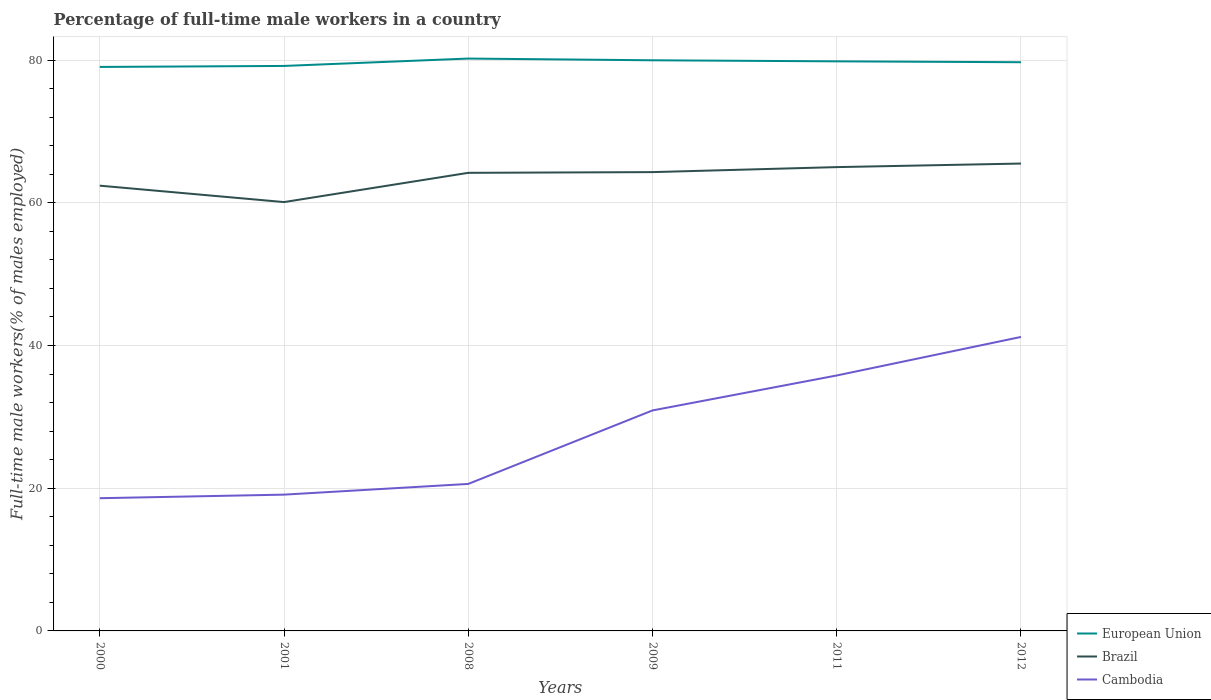How many different coloured lines are there?
Ensure brevity in your answer.  3. Is the number of lines equal to the number of legend labels?
Provide a short and direct response. Yes. Across all years, what is the maximum percentage of full-time male workers in European Union?
Keep it short and to the point. 79.04. In which year was the percentage of full-time male workers in European Union maximum?
Ensure brevity in your answer.  2000. What is the total percentage of full-time male workers in Brazil in the graph?
Give a very brief answer. -4.2. What is the difference between the highest and the second highest percentage of full-time male workers in Cambodia?
Your response must be concise. 22.6. Is the percentage of full-time male workers in Cambodia strictly greater than the percentage of full-time male workers in Brazil over the years?
Give a very brief answer. Yes. How many lines are there?
Your response must be concise. 3. What is the difference between two consecutive major ticks on the Y-axis?
Keep it short and to the point. 20. Does the graph contain any zero values?
Keep it short and to the point. No. Does the graph contain grids?
Provide a short and direct response. Yes. How many legend labels are there?
Provide a short and direct response. 3. What is the title of the graph?
Ensure brevity in your answer.  Percentage of full-time male workers in a country. What is the label or title of the Y-axis?
Provide a short and direct response. Full-time male workers(% of males employed). What is the Full-time male workers(% of males employed) of European Union in 2000?
Provide a short and direct response. 79.04. What is the Full-time male workers(% of males employed) in Brazil in 2000?
Offer a terse response. 62.4. What is the Full-time male workers(% of males employed) in Cambodia in 2000?
Keep it short and to the point. 18.6. What is the Full-time male workers(% of males employed) in European Union in 2001?
Your answer should be compact. 79.18. What is the Full-time male workers(% of males employed) of Brazil in 2001?
Provide a short and direct response. 60.1. What is the Full-time male workers(% of males employed) in Cambodia in 2001?
Offer a terse response. 19.1. What is the Full-time male workers(% of males employed) of European Union in 2008?
Keep it short and to the point. 80.21. What is the Full-time male workers(% of males employed) of Brazil in 2008?
Offer a very short reply. 64.2. What is the Full-time male workers(% of males employed) of Cambodia in 2008?
Offer a terse response. 20.6. What is the Full-time male workers(% of males employed) of European Union in 2009?
Your answer should be very brief. 79.97. What is the Full-time male workers(% of males employed) of Brazil in 2009?
Offer a terse response. 64.3. What is the Full-time male workers(% of males employed) in Cambodia in 2009?
Provide a succinct answer. 30.9. What is the Full-time male workers(% of males employed) in European Union in 2011?
Your answer should be very brief. 79.82. What is the Full-time male workers(% of males employed) in Cambodia in 2011?
Offer a very short reply. 35.8. What is the Full-time male workers(% of males employed) of European Union in 2012?
Provide a short and direct response. 79.7. What is the Full-time male workers(% of males employed) in Brazil in 2012?
Your answer should be compact. 65.5. What is the Full-time male workers(% of males employed) in Cambodia in 2012?
Provide a short and direct response. 41.2. Across all years, what is the maximum Full-time male workers(% of males employed) of European Union?
Your answer should be compact. 80.21. Across all years, what is the maximum Full-time male workers(% of males employed) of Brazil?
Offer a terse response. 65.5. Across all years, what is the maximum Full-time male workers(% of males employed) of Cambodia?
Your answer should be very brief. 41.2. Across all years, what is the minimum Full-time male workers(% of males employed) in European Union?
Offer a very short reply. 79.04. Across all years, what is the minimum Full-time male workers(% of males employed) of Brazil?
Provide a succinct answer. 60.1. Across all years, what is the minimum Full-time male workers(% of males employed) in Cambodia?
Your answer should be very brief. 18.6. What is the total Full-time male workers(% of males employed) of European Union in the graph?
Make the answer very short. 477.93. What is the total Full-time male workers(% of males employed) of Brazil in the graph?
Your response must be concise. 381.5. What is the total Full-time male workers(% of males employed) of Cambodia in the graph?
Offer a very short reply. 166.2. What is the difference between the Full-time male workers(% of males employed) in European Union in 2000 and that in 2001?
Offer a terse response. -0.14. What is the difference between the Full-time male workers(% of males employed) in European Union in 2000 and that in 2008?
Your answer should be very brief. -1.18. What is the difference between the Full-time male workers(% of males employed) of European Union in 2000 and that in 2009?
Provide a short and direct response. -0.93. What is the difference between the Full-time male workers(% of males employed) in European Union in 2000 and that in 2011?
Offer a terse response. -0.78. What is the difference between the Full-time male workers(% of males employed) in Cambodia in 2000 and that in 2011?
Your response must be concise. -17.2. What is the difference between the Full-time male workers(% of males employed) in European Union in 2000 and that in 2012?
Provide a succinct answer. -0.66. What is the difference between the Full-time male workers(% of males employed) of Brazil in 2000 and that in 2012?
Offer a very short reply. -3.1. What is the difference between the Full-time male workers(% of males employed) of Cambodia in 2000 and that in 2012?
Your response must be concise. -22.6. What is the difference between the Full-time male workers(% of males employed) of European Union in 2001 and that in 2008?
Offer a very short reply. -1.03. What is the difference between the Full-time male workers(% of males employed) in European Union in 2001 and that in 2009?
Offer a terse response. -0.79. What is the difference between the Full-time male workers(% of males employed) of Brazil in 2001 and that in 2009?
Provide a succinct answer. -4.2. What is the difference between the Full-time male workers(% of males employed) of Cambodia in 2001 and that in 2009?
Provide a succinct answer. -11.8. What is the difference between the Full-time male workers(% of males employed) of European Union in 2001 and that in 2011?
Your response must be concise. -0.64. What is the difference between the Full-time male workers(% of males employed) in Brazil in 2001 and that in 2011?
Your answer should be very brief. -4.9. What is the difference between the Full-time male workers(% of males employed) of Cambodia in 2001 and that in 2011?
Your answer should be very brief. -16.7. What is the difference between the Full-time male workers(% of males employed) in European Union in 2001 and that in 2012?
Offer a terse response. -0.52. What is the difference between the Full-time male workers(% of males employed) of Cambodia in 2001 and that in 2012?
Your response must be concise. -22.1. What is the difference between the Full-time male workers(% of males employed) in European Union in 2008 and that in 2009?
Offer a very short reply. 0.24. What is the difference between the Full-time male workers(% of males employed) of Cambodia in 2008 and that in 2009?
Provide a short and direct response. -10.3. What is the difference between the Full-time male workers(% of males employed) of European Union in 2008 and that in 2011?
Offer a very short reply. 0.39. What is the difference between the Full-time male workers(% of males employed) in Brazil in 2008 and that in 2011?
Ensure brevity in your answer.  -0.8. What is the difference between the Full-time male workers(% of males employed) of Cambodia in 2008 and that in 2011?
Your response must be concise. -15.2. What is the difference between the Full-time male workers(% of males employed) of European Union in 2008 and that in 2012?
Give a very brief answer. 0.51. What is the difference between the Full-time male workers(% of males employed) of Cambodia in 2008 and that in 2012?
Make the answer very short. -20.6. What is the difference between the Full-time male workers(% of males employed) in European Union in 2009 and that in 2011?
Make the answer very short. 0.15. What is the difference between the Full-time male workers(% of males employed) of Cambodia in 2009 and that in 2011?
Offer a very short reply. -4.9. What is the difference between the Full-time male workers(% of males employed) of European Union in 2009 and that in 2012?
Make the answer very short. 0.27. What is the difference between the Full-time male workers(% of males employed) in European Union in 2011 and that in 2012?
Give a very brief answer. 0.12. What is the difference between the Full-time male workers(% of males employed) of Brazil in 2011 and that in 2012?
Make the answer very short. -0.5. What is the difference between the Full-time male workers(% of males employed) in European Union in 2000 and the Full-time male workers(% of males employed) in Brazil in 2001?
Ensure brevity in your answer.  18.94. What is the difference between the Full-time male workers(% of males employed) of European Union in 2000 and the Full-time male workers(% of males employed) of Cambodia in 2001?
Your answer should be very brief. 59.94. What is the difference between the Full-time male workers(% of males employed) of Brazil in 2000 and the Full-time male workers(% of males employed) of Cambodia in 2001?
Your answer should be compact. 43.3. What is the difference between the Full-time male workers(% of males employed) of European Union in 2000 and the Full-time male workers(% of males employed) of Brazil in 2008?
Your response must be concise. 14.84. What is the difference between the Full-time male workers(% of males employed) of European Union in 2000 and the Full-time male workers(% of males employed) of Cambodia in 2008?
Provide a short and direct response. 58.44. What is the difference between the Full-time male workers(% of males employed) in Brazil in 2000 and the Full-time male workers(% of males employed) in Cambodia in 2008?
Provide a short and direct response. 41.8. What is the difference between the Full-time male workers(% of males employed) of European Union in 2000 and the Full-time male workers(% of males employed) of Brazil in 2009?
Make the answer very short. 14.74. What is the difference between the Full-time male workers(% of males employed) in European Union in 2000 and the Full-time male workers(% of males employed) in Cambodia in 2009?
Your answer should be very brief. 48.14. What is the difference between the Full-time male workers(% of males employed) of Brazil in 2000 and the Full-time male workers(% of males employed) of Cambodia in 2009?
Your response must be concise. 31.5. What is the difference between the Full-time male workers(% of males employed) of European Union in 2000 and the Full-time male workers(% of males employed) of Brazil in 2011?
Provide a succinct answer. 14.04. What is the difference between the Full-time male workers(% of males employed) of European Union in 2000 and the Full-time male workers(% of males employed) of Cambodia in 2011?
Your response must be concise. 43.24. What is the difference between the Full-time male workers(% of males employed) of Brazil in 2000 and the Full-time male workers(% of males employed) of Cambodia in 2011?
Make the answer very short. 26.6. What is the difference between the Full-time male workers(% of males employed) of European Union in 2000 and the Full-time male workers(% of males employed) of Brazil in 2012?
Keep it short and to the point. 13.54. What is the difference between the Full-time male workers(% of males employed) in European Union in 2000 and the Full-time male workers(% of males employed) in Cambodia in 2012?
Your response must be concise. 37.84. What is the difference between the Full-time male workers(% of males employed) in Brazil in 2000 and the Full-time male workers(% of males employed) in Cambodia in 2012?
Your answer should be compact. 21.2. What is the difference between the Full-time male workers(% of males employed) of European Union in 2001 and the Full-time male workers(% of males employed) of Brazil in 2008?
Keep it short and to the point. 14.98. What is the difference between the Full-time male workers(% of males employed) of European Union in 2001 and the Full-time male workers(% of males employed) of Cambodia in 2008?
Make the answer very short. 58.58. What is the difference between the Full-time male workers(% of males employed) of Brazil in 2001 and the Full-time male workers(% of males employed) of Cambodia in 2008?
Offer a terse response. 39.5. What is the difference between the Full-time male workers(% of males employed) in European Union in 2001 and the Full-time male workers(% of males employed) in Brazil in 2009?
Keep it short and to the point. 14.88. What is the difference between the Full-time male workers(% of males employed) of European Union in 2001 and the Full-time male workers(% of males employed) of Cambodia in 2009?
Offer a very short reply. 48.28. What is the difference between the Full-time male workers(% of males employed) of Brazil in 2001 and the Full-time male workers(% of males employed) of Cambodia in 2009?
Your answer should be compact. 29.2. What is the difference between the Full-time male workers(% of males employed) in European Union in 2001 and the Full-time male workers(% of males employed) in Brazil in 2011?
Your answer should be compact. 14.18. What is the difference between the Full-time male workers(% of males employed) of European Union in 2001 and the Full-time male workers(% of males employed) of Cambodia in 2011?
Give a very brief answer. 43.38. What is the difference between the Full-time male workers(% of males employed) of Brazil in 2001 and the Full-time male workers(% of males employed) of Cambodia in 2011?
Make the answer very short. 24.3. What is the difference between the Full-time male workers(% of males employed) of European Union in 2001 and the Full-time male workers(% of males employed) of Brazil in 2012?
Provide a succinct answer. 13.68. What is the difference between the Full-time male workers(% of males employed) of European Union in 2001 and the Full-time male workers(% of males employed) of Cambodia in 2012?
Make the answer very short. 37.98. What is the difference between the Full-time male workers(% of males employed) of European Union in 2008 and the Full-time male workers(% of males employed) of Brazil in 2009?
Your answer should be compact. 15.91. What is the difference between the Full-time male workers(% of males employed) in European Union in 2008 and the Full-time male workers(% of males employed) in Cambodia in 2009?
Your answer should be compact. 49.31. What is the difference between the Full-time male workers(% of males employed) in Brazil in 2008 and the Full-time male workers(% of males employed) in Cambodia in 2009?
Give a very brief answer. 33.3. What is the difference between the Full-time male workers(% of males employed) of European Union in 2008 and the Full-time male workers(% of males employed) of Brazil in 2011?
Make the answer very short. 15.21. What is the difference between the Full-time male workers(% of males employed) of European Union in 2008 and the Full-time male workers(% of males employed) of Cambodia in 2011?
Your response must be concise. 44.41. What is the difference between the Full-time male workers(% of males employed) of Brazil in 2008 and the Full-time male workers(% of males employed) of Cambodia in 2011?
Offer a very short reply. 28.4. What is the difference between the Full-time male workers(% of males employed) in European Union in 2008 and the Full-time male workers(% of males employed) in Brazil in 2012?
Offer a terse response. 14.71. What is the difference between the Full-time male workers(% of males employed) in European Union in 2008 and the Full-time male workers(% of males employed) in Cambodia in 2012?
Keep it short and to the point. 39.01. What is the difference between the Full-time male workers(% of males employed) of European Union in 2009 and the Full-time male workers(% of males employed) of Brazil in 2011?
Make the answer very short. 14.97. What is the difference between the Full-time male workers(% of males employed) of European Union in 2009 and the Full-time male workers(% of males employed) of Cambodia in 2011?
Offer a very short reply. 44.17. What is the difference between the Full-time male workers(% of males employed) in European Union in 2009 and the Full-time male workers(% of males employed) in Brazil in 2012?
Give a very brief answer. 14.47. What is the difference between the Full-time male workers(% of males employed) in European Union in 2009 and the Full-time male workers(% of males employed) in Cambodia in 2012?
Give a very brief answer. 38.77. What is the difference between the Full-time male workers(% of males employed) of Brazil in 2009 and the Full-time male workers(% of males employed) of Cambodia in 2012?
Your response must be concise. 23.1. What is the difference between the Full-time male workers(% of males employed) in European Union in 2011 and the Full-time male workers(% of males employed) in Brazil in 2012?
Your answer should be very brief. 14.32. What is the difference between the Full-time male workers(% of males employed) in European Union in 2011 and the Full-time male workers(% of males employed) in Cambodia in 2012?
Offer a very short reply. 38.62. What is the difference between the Full-time male workers(% of males employed) of Brazil in 2011 and the Full-time male workers(% of males employed) of Cambodia in 2012?
Give a very brief answer. 23.8. What is the average Full-time male workers(% of males employed) of European Union per year?
Your answer should be very brief. 79.65. What is the average Full-time male workers(% of males employed) of Brazil per year?
Provide a short and direct response. 63.58. What is the average Full-time male workers(% of males employed) in Cambodia per year?
Provide a short and direct response. 27.7. In the year 2000, what is the difference between the Full-time male workers(% of males employed) in European Union and Full-time male workers(% of males employed) in Brazil?
Give a very brief answer. 16.64. In the year 2000, what is the difference between the Full-time male workers(% of males employed) in European Union and Full-time male workers(% of males employed) in Cambodia?
Offer a terse response. 60.44. In the year 2000, what is the difference between the Full-time male workers(% of males employed) in Brazil and Full-time male workers(% of males employed) in Cambodia?
Offer a very short reply. 43.8. In the year 2001, what is the difference between the Full-time male workers(% of males employed) in European Union and Full-time male workers(% of males employed) in Brazil?
Make the answer very short. 19.08. In the year 2001, what is the difference between the Full-time male workers(% of males employed) of European Union and Full-time male workers(% of males employed) of Cambodia?
Keep it short and to the point. 60.08. In the year 2008, what is the difference between the Full-time male workers(% of males employed) in European Union and Full-time male workers(% of males employed) in Brazil?
Your answer should be compact. 16.01. In the year 2008, what is the difference between the Full-time male workers(% of males employed) in European Union and Full-time male workers(% of males employed) in Cambodia?
Offer a terse response. 59.61. In the year 2008, what is the difference between the Full-time male workers(% of males employed) of Brazil and Full-time male workers(% of males employed) of Cambodia?
Ensure brevity in your answer.  43.6. In the year 2009, what is the difference between the Full-time male workers(% of males employed) of European Union and Full-time male workers(% of males employed) of Brazil?
Your answer should be compact. 15.67. In the year 2009, what is the difference between the Full-time male workers(% of males employed) in European Union and Full-time male workers(% of males employed) in Cambodia?
Offer a terse response. 49.07. In the year 2009, what is the difference between the Full-time male workers(% of males employed) in Brazil and Full-time male workers(% of males employed) in Cambodia?
Your answer should be compact. 33.4. In the year 2011, what is the difference between the Full-time male workers(% of males employed) of European Union and Full-time male workers(% of males employed) of Brazil?
Provide a short and direct response. 14.82. In the year 2011, what is the difference between the Full-time male workers(% of males employed) in European Union and Full-time male workers(% of males employed) in Cambodia?
Offer a terse response. 44.02. In the year 2011, what is the difference between the Full-time male workers(% of males employed) of Brazil and Full-time male workers(% of males employed) of Cambodia?
Offer a terse response. 29.2. In the year 2012, what is the difference between the Full-time male workers(% of males employed) of European Union and Full-time male workers(% of males employed) of Brazil?
Offer a very short reply. 14.2. In the year 2012, what is the difference between the Full-time male workers(% of males employed) in European Union and Full-time male workers(% of males employed) in Cambodia?
Provide a short and direct response. 38.5. In the year 2012, what is the difference between the Full-time male workers(% of males employed) in Brazil and Full-time male workers(% of males employed) in Cambodia?
Your response must be concise. 24.3. What is the ratio of the Full-time male workers(% of males employed) in European Union in 2000 to that in 2001?
Offer a terse response. 1. What is the ratio of the Full-time male workers(% of males employed) in Brazil in 2000 to that in 2001?
Your response must be concise. 1.04. What is the ratio of the Full-time male workers(% of males employed) in Cambodia in 2000 to that in 2001?
Offer a terse response. 0.97. What is the ratio of the Full-time male workers(% of males employed) in Brazil in 2000 to that in 2008?
Make the answer very short. 0.97. What is the ratio of the Full-time male workers(% of males employed) of Cambodia in 2000 to that in 2008?
Keep it short and to the point. 0.9. What is the ratio of the Full-time male workers(% of males employed) in European Union in 2000 to that in 2009?
Ensure brevity in your answer.  0.99. What is the ratio of the Full-time male workers(% of males employed) of Brazil in 2000 to that in 2009?
Your response must be concise. 0.97. What is the ratio of the Full-time male workers(% of males employed) in Cambodia in 2000 to that in 2009?
Provide a succinct answer. 0.6. What is the ratio of the Full-time male workers(% of males employed) of European Union in 2000 to that in 2011?
Provide a short and direct response. 0.99. What is the ratio of the Full-time male workers(% of males employed) of Brazil in 2000 to that in 2011?
Keep it short and to the point. 0.96. What is the ratio of the Full-time male workers(% of males employed) in Cambodia in 2000 to that in 2011?
Your answer should be compact. 0.52. What is the ratio of the Full-time male workers(% of males employed) in European Union in 2000 to that in 2012?
Offer a terse response. 0.99. What is the ratio of the Full-time male workers(% of males employed) of Brazil in 2000 to that in 2012?
Your answer should be compact. 0.95. What is the ratio of the Full-time male workers(% of males employed) of Cambodia in 2000 to that in 2012?
Give a very brief answer. 0.45. What is the ratio of the Full-time male workers(% of males employed) in European Union in 2001 to that in 2008?
Your answer should be compact. 0.99. What is the ratio of the Full-time male workers(% of males employed) in Brazil in 2001 to that in 2008?
Offer a terse response. 0.94. What is the ratio of the Full-time male workers(% of males employed) of Cambodia in 2001 to that in 2008?
Offer a terse response. 0.93. What is the ratio of the Full-time male workers(% of males employed) of European Union in 2001 to that in 2009?
Offer a terse response. 0.99. What is the ratio of the Full-time male workers(% of males employed) of Brazil in 2001 to that in 2009?
Offer a terse response. 0.93. What is the ratio of the Full-time male workers(% of males employed) of Cambodia in 2001 to that in 2009?
Give a very brief answer. 0.62. What is the ratio of the Full-time male workers(% of males employed) in European Union in 2001 to that in 2011?
Provide a short and direct response. 0.99. What is the ratio of the Full-time male workers(% of males employed) in Brazil in 2001 to that in 2011?
Provide a short and direct response. 0.92. What is the ratio of the Full-time male workers(% of males employed) of Cambodia in 2001 to that in 2011?
Your answer should be very brief. 0.53. What is the ratio of the Full-time male workers(% of males employed) of Brazil in 2001 to that in 2012?
Ensure brevity in your answer.  0.92. What is the ratio of the Full-time male workers(% of males employed) of Cambodia in 2001 to that in 2012?
Give a very brief answer. 0.46. What is the ratio of the Full-time male workers(% of males employed) in European Union in 2008 to that in 2009?
Keep it short and to the point. 1. What is the ratio of the Full-time male workers(% of males employed) in Brazil in 2008 to that in 2011?
Provide a succinct answer. 0.99. What is the ratio of the Full-time male workers(% of males employed) in Cambodia in 2008 to that in 2011?
Ensure brevity in your answer.  0.58. What is the ratio of the Full-time male workers(% of males employed) of European Union in 2008 to that in 2012?
Your answer should be compact. 1.01. What is the ratio of the Full-time male workers(% of males employed) in Brazil in 2008 to that in 2012?
Keep it short and to the point. 0.98. What is the ratio of the Full-time male workers(% of males employed) of Cambodia in 2008 to that in 2012?
Keep it short and to the point. 0.5. What is the ratio of the Full-time male workers(% of males employed) in Cambodia in 2009 to that in 2011?
Provide a short and direct response. 0.86. What is the ratio of the Full-time male workers(% of males employed) of Brazil in 2009 to that in 2012?
Give a very brief answer. 0.98. What is the ratio of the Full-time male workers(% of males employed) of Cambodia in 2009 to that in 2012?
Your answer should be compact. 0.75. What is the ratio of the Full-time male workers(% of males employed) of Brazil in 2011 to that in 2012?
Your answer should be compact. 0.99. What is the ratio of the Full-time male workers(% of males employed) of Cambodia in 2011 to that in 2012?
Your response must be concise. 0.87. What is the difference between the highest and the second highest Full-time male workers(% of males employed) in European Union?
Offer a terse response. 0.24. What is the difference between the highest and the second highest Full-time male workers(% of males employed) of Brazil?
Ensure brevity in your answer.  0.5. What is the difference between the highest and the second highest Full-time male workers(% of males employed) of Cambodia?
Your answer should be very brief. 5.4. What is the difference between the highest and the lowest Full-time male workers(% of males employed) of European Union?
Offer a terse response. 1.18. What is the difference between the highest and the lowest Full-time male workers(% of males employed) of Brazil?
Your answer should be very brief. 5.4. What is the difference between the highest and the lowest Full-time male workers(% of males employed) in Cambodia?
Give a very brief answer. 22.6. 